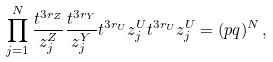<formula> <loc_0><loc_0><loc_500><loc_500>\prod _ { j = 1 } ^ { N } \frac { t ^ { 3 r _ { Z } } } { z ^ { Z } _ { j } } \frac { t ^ { 3 r _ { Y } } } { z ^ { Y } _ { j } } t ^ { 3 r _ { U } } z ^ { U } _ { j } t ^ { 3 r _ { U } } z ^ { U } _ { j } = ( p q ) ^ { N } \, ,</formula> 